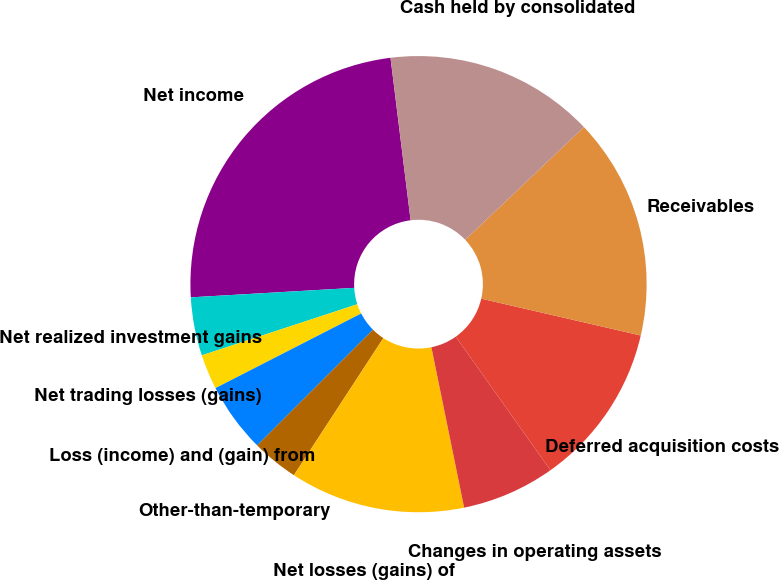<chart> <loc_0><loc_0><loc_500><loc_500><pie_chart><fcel>Net income<fcel>Net realized investment gains<fcel>Net trading losses (gains)<fcel>Loss (income) and (gain) from<fcel>Other-than-temporary<fcel>Net losses (gains) of<fcel>Changes in operating assets<fcel>Deferred acquisition costs<fcel>Receivables<fcel>Cash held by consolidated<nl><fcel>23.96%<fcel>4.13%<fcel>2.48%<fcel>4.96%<fcel>3.31%<fcel>12.4%<fcel>6.61%<fcel>11.57%<fcel>15.7%<fcel>14.87%<nl></chart> 